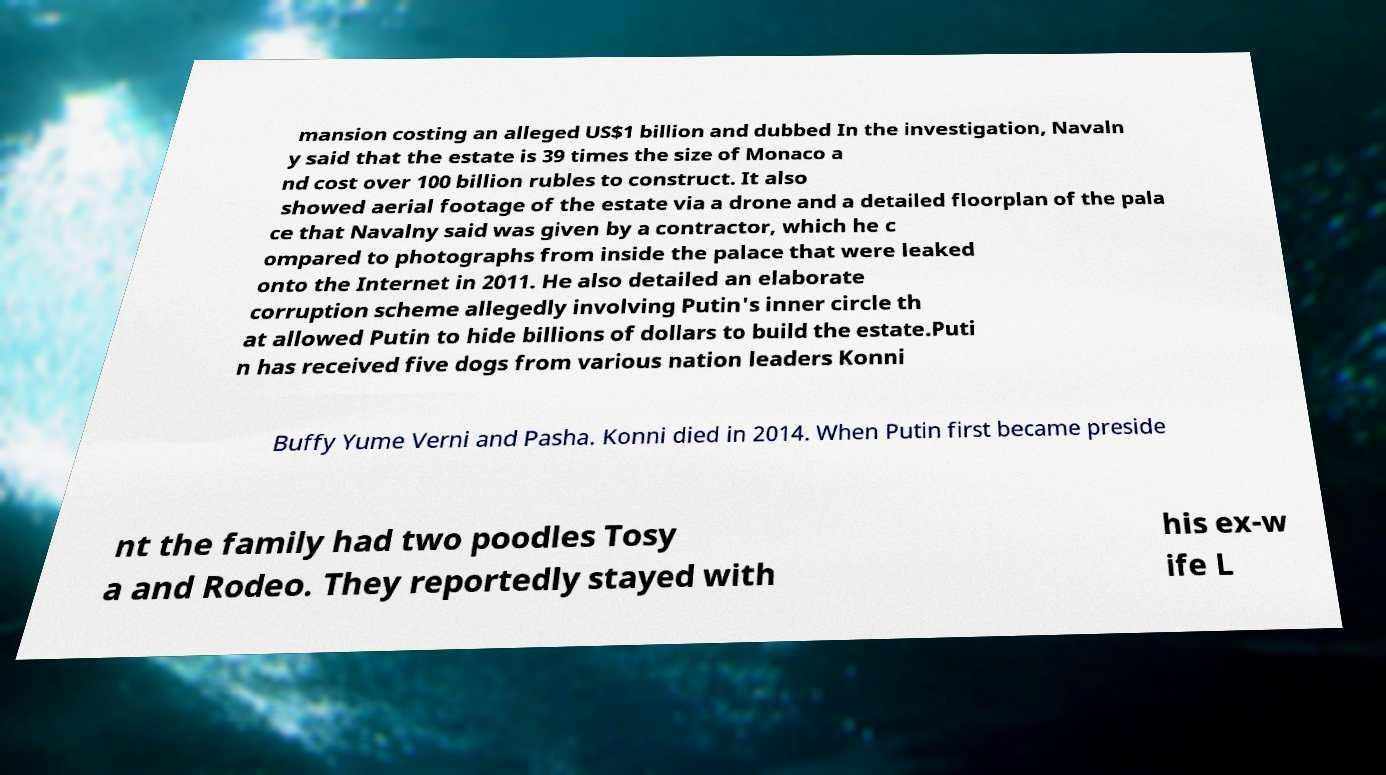Can you read and provide the text displayed in the image?This photo seems to have some interesting text. Can you extract and type it out for me? mansion costing an alleged US$1 billion and dubbed In the investigation, Navaln y said that the estate is 39 times the size of Monaco a nd cost over 100 billion rubles to construct. It also showed aerial footage of the estate via a drone and a detailed floorplan of the pala ce that Navalny said was given by a contractor, which he c ompared to photographs from inside the palace that were leaked onto the Internet in 2011. He also detailed an elaborate corruption scheme allegedly involving Putin's inner circle th at allowed Putin to hide billions of dollars to build the estate.Puti n has received five dogs from various nation leaders Konni Buffy Yume Verni and Pasha. Konni died in 2014. When Putin first became preside nt the family had two poodles Tosy a and Rodeo. They reportedly stayed with his ex-w ife L 